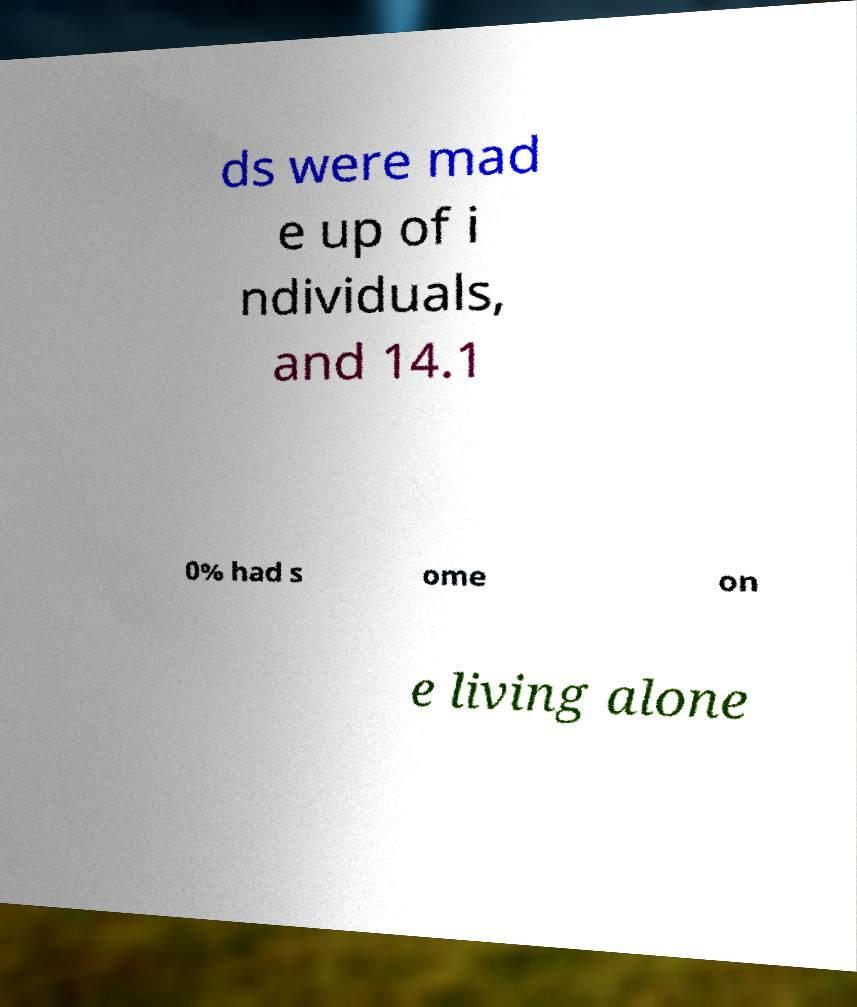Could you extract and type out the text from this image? ds were mad e up of i ndividuals, and 14.1 0% had s ome on e living alone 